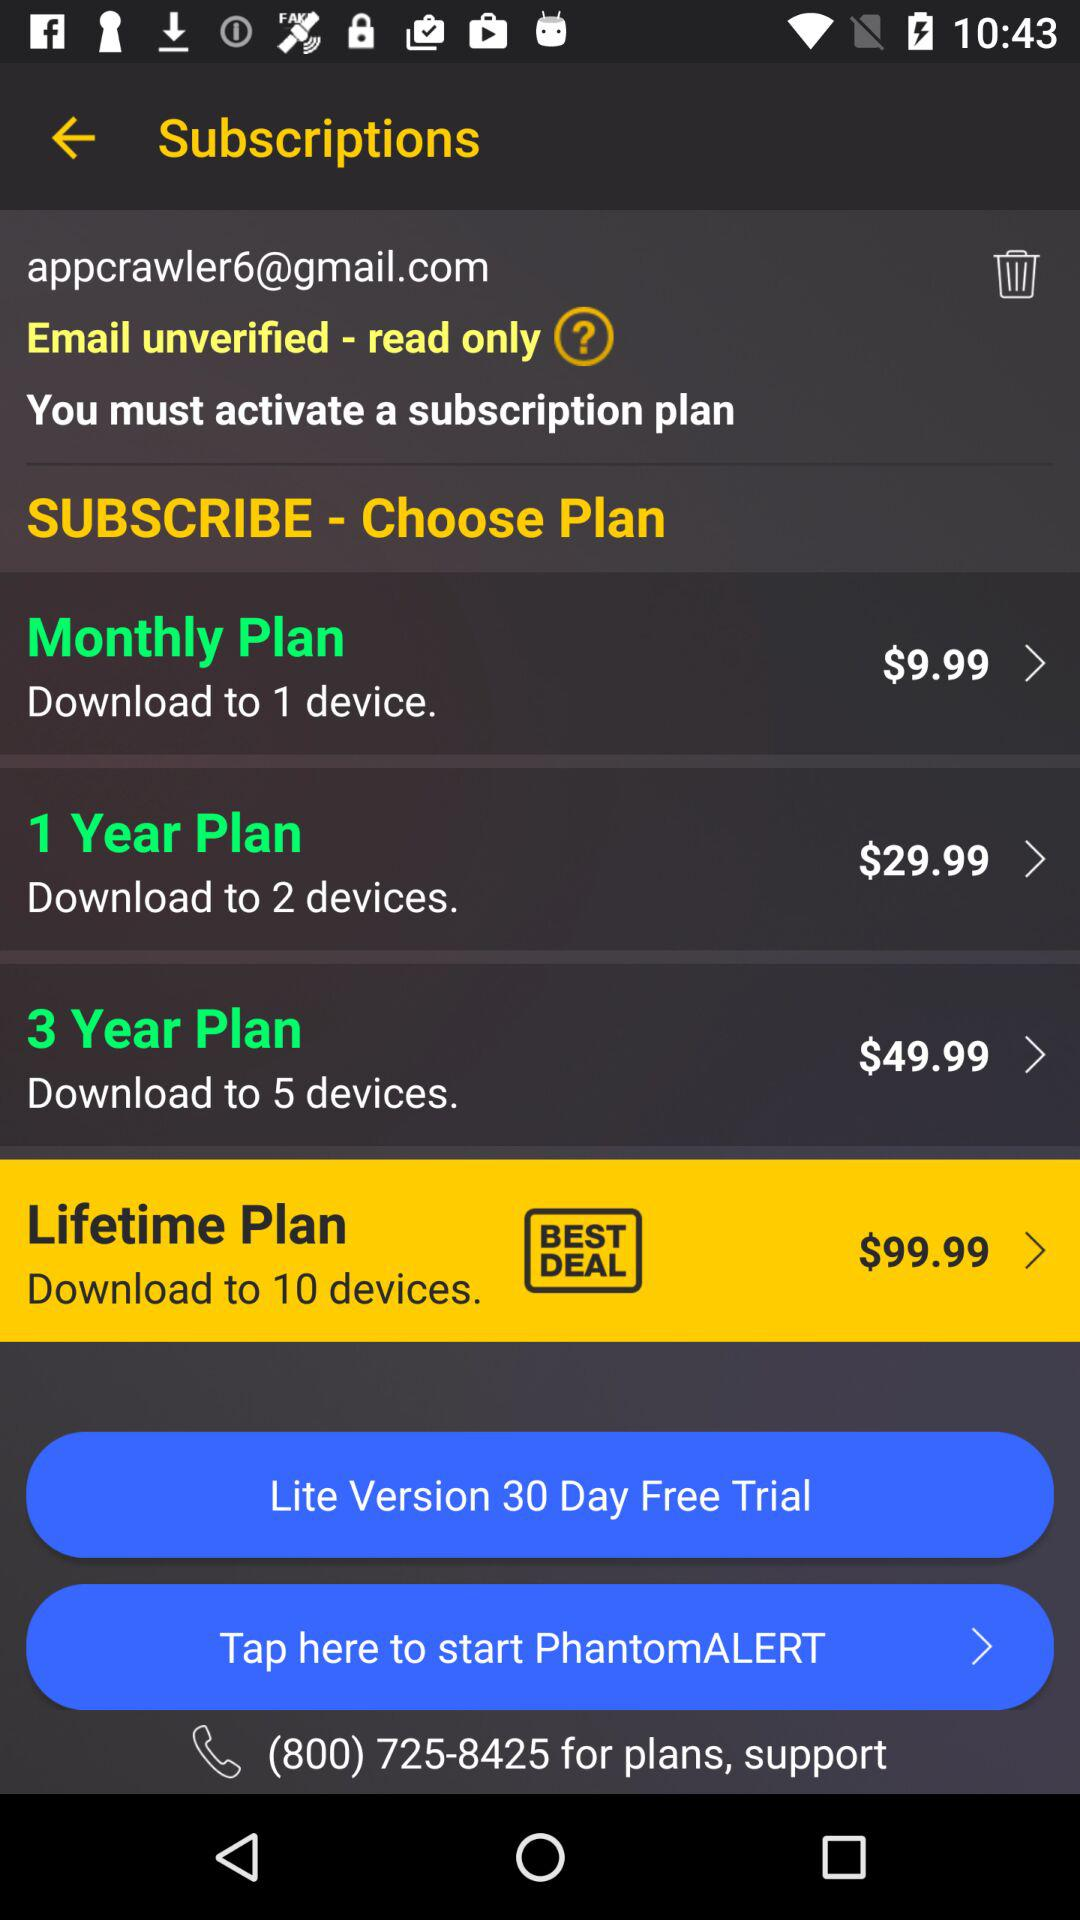Which plan is the $99.99 for? The $99.99 is for the "Monthly Plan". 